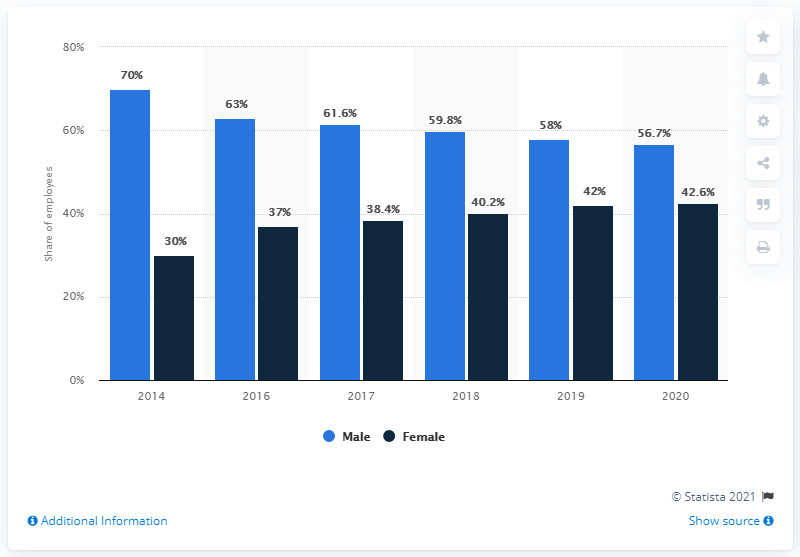Can you explain why there might be a sudden drop in the male percentage in 2016 compared to 2014? While the chart doesn't provide specific reasons for the sudden drop in the male percentage from 70% to 63% between 2014 and 2016, it could be attributed to a variety of factors such as proactive diversity hiring policies, natural fluctuations in employment, or sector-specific changes such as shifting job demands that attracted more female professionals. 